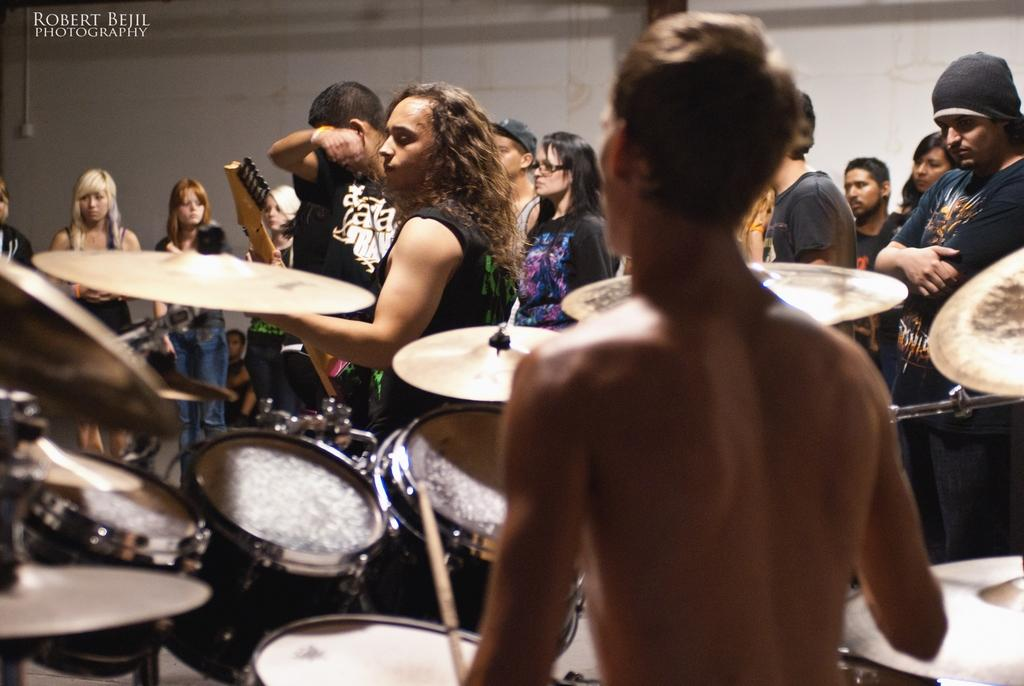What is the main subject of the image? There is a man in the image. What is the man doing in the image? The man is standing and beating drums. Are there any other people in the image? Yes, there are people standing in the image. What type of beetle can be seen crawling on the man's drum in the image? There is no beetle present in the image; it only features a man beating drums and other people standing nearby. 